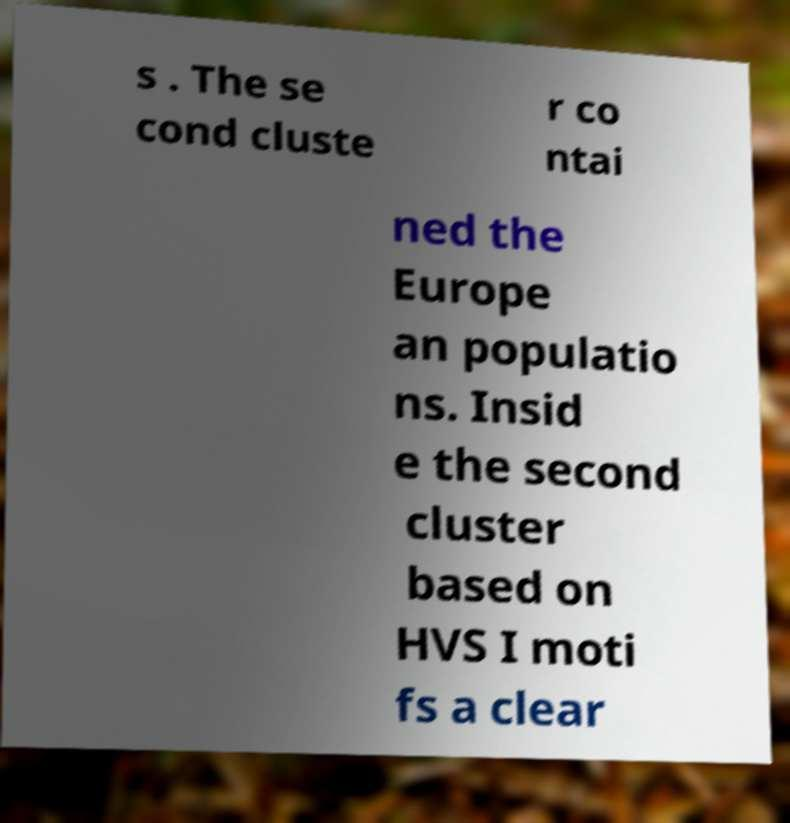Can you accurately transcribe the text from the provided image for me? s . The se cond cluste r co ntai ned the Europe an populatio ns. Insid e the second cluster based on HVS I moti fs a clear 